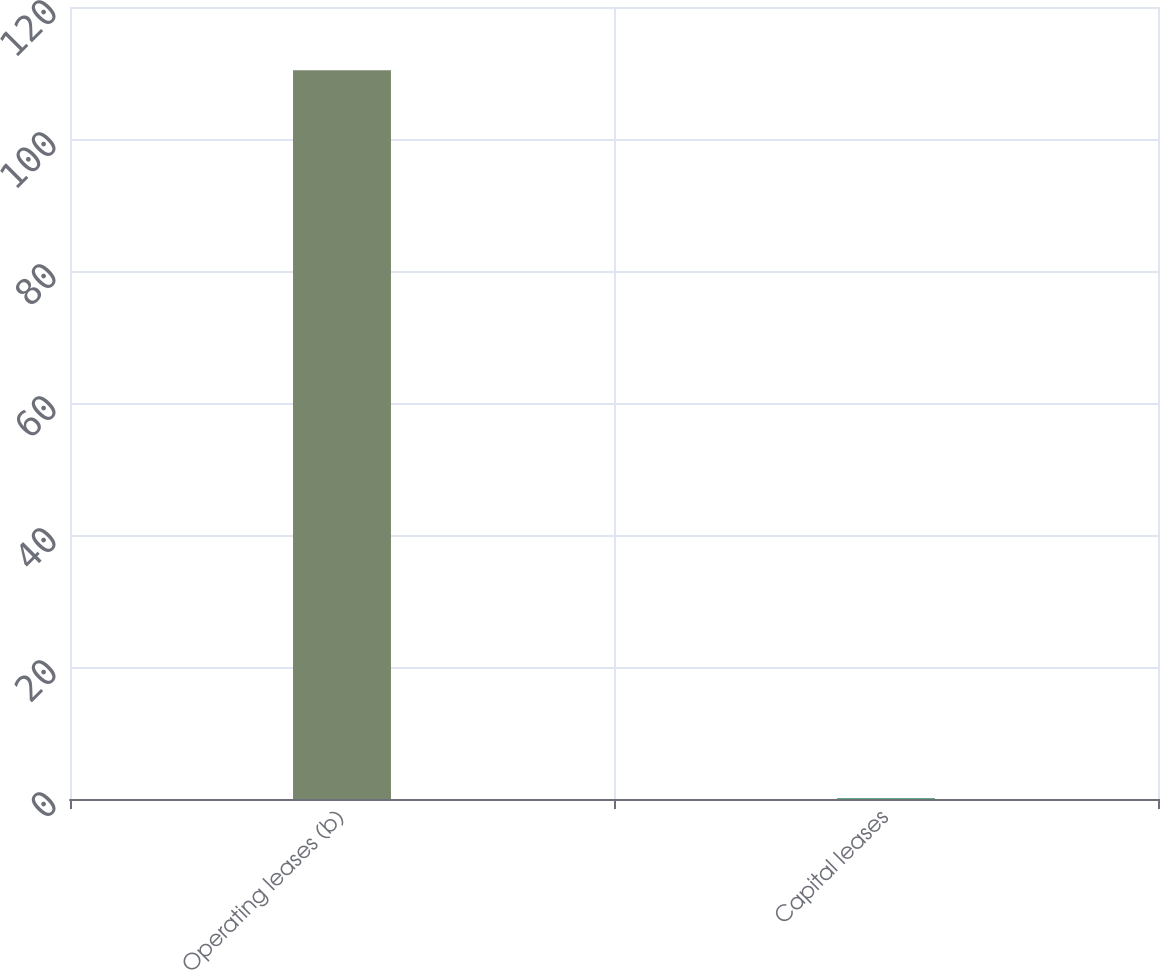Convert chart to OTSL. <chart><loc_0><loc_0><loc_500><loc_500><bar_chart><fcel>Operating leases (b)<fcel>Capital leases<nl><fcel>110.4<fcel>0.1<nl></chart> 